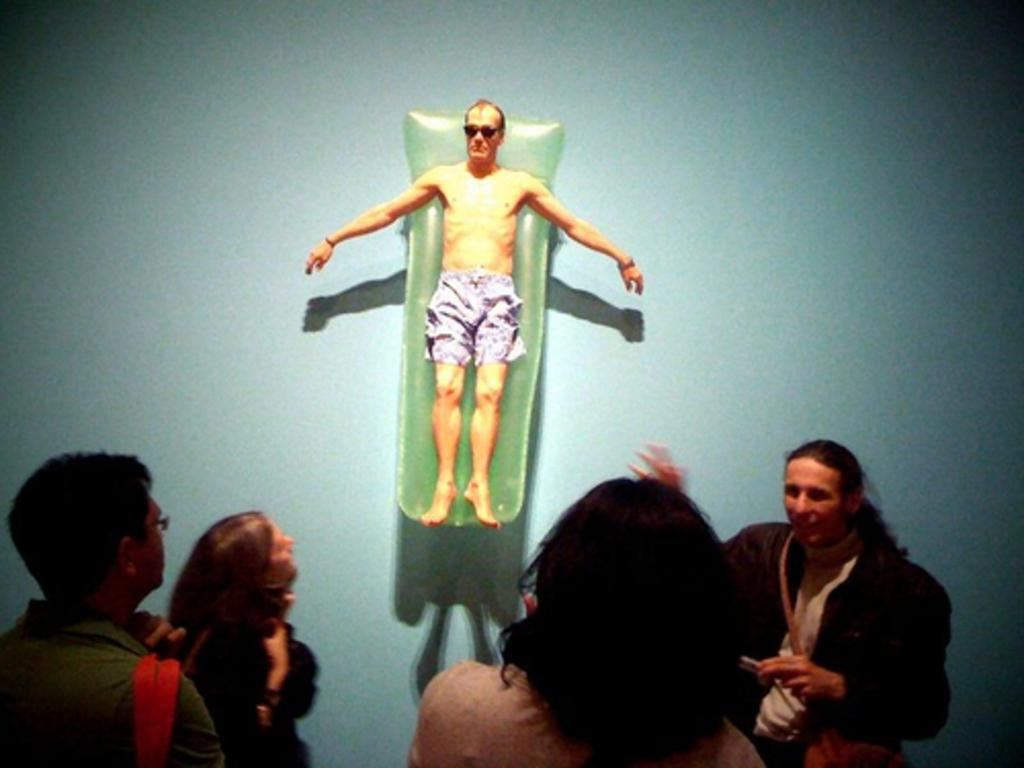What is happening in the image? There are people standing in the image. Can you describe the position of one person in the image? One person is lying on a green object. What is the color of the surface the green object is on? The green object is on a blue surface. What is the limit of the effect of the authority in the image? There is no mention of limits, effects, or authority in the image, as it only features people standing and one person lying on a green object on a blue surface. 